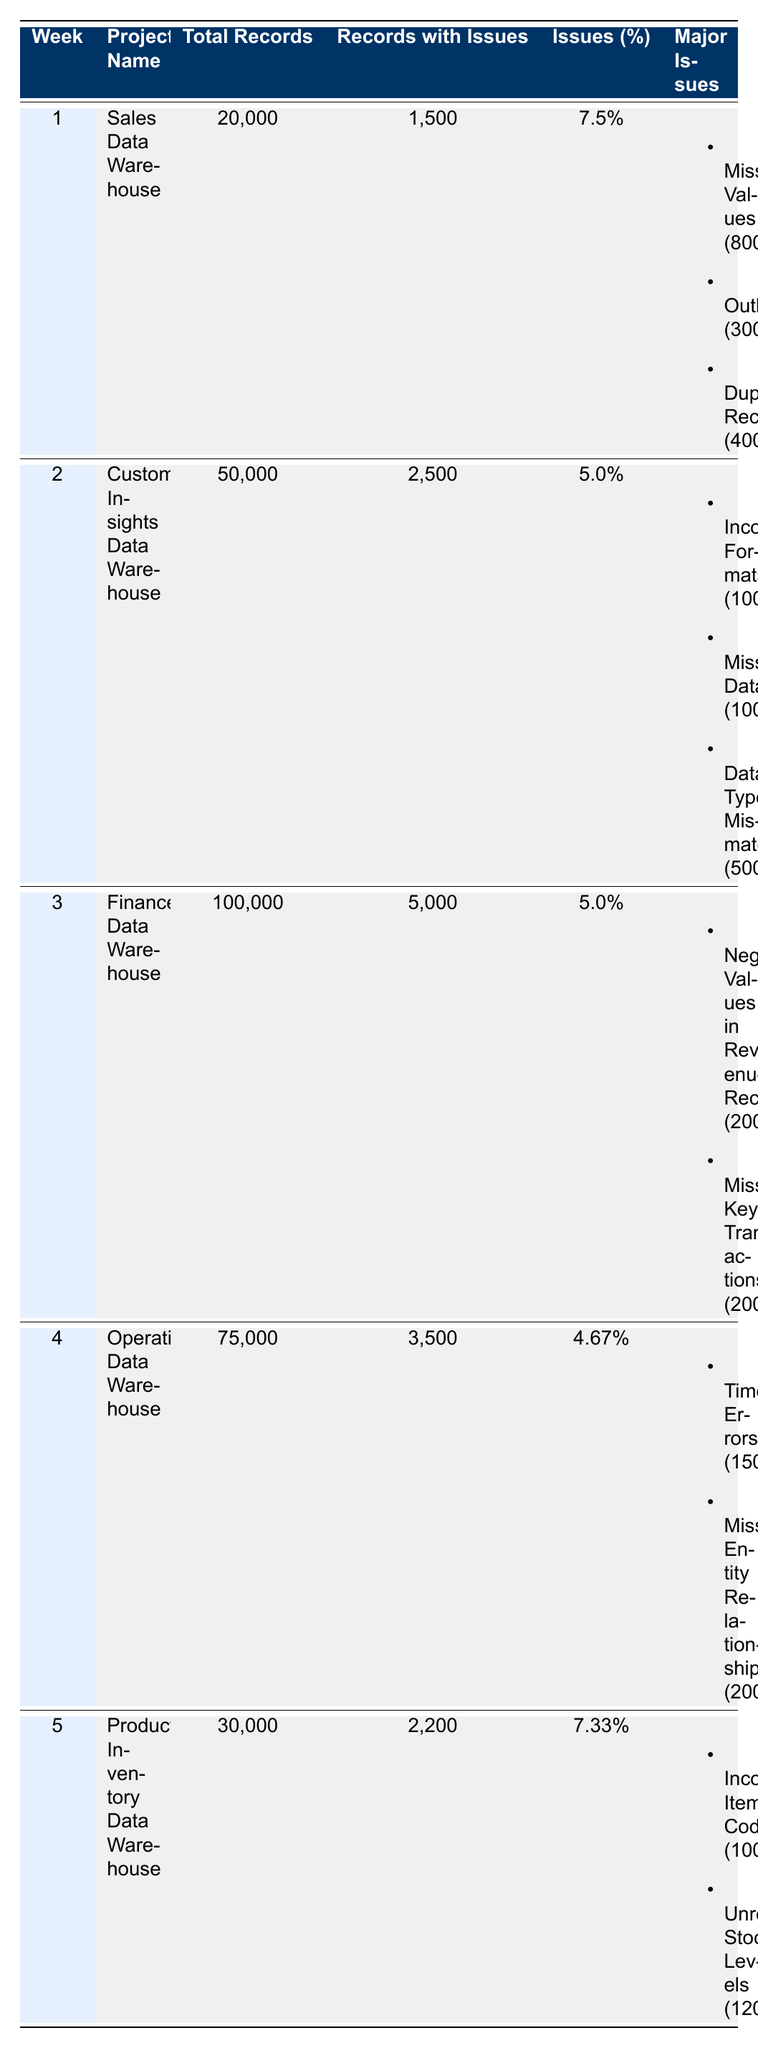What was the total number of records checked for the Finance Data Warehouse? The table shows that the total records checked for the Finance Data Warehouse on January 23, 2023, were 100,000.
Answer: 100000 How many records had issues in the Customer Insights Data Warehouse? According to the table, the Customer Insights Data Warehouse had 2,500 records with issues on January 16, 2023.
Answer: 2500 Which project had the highest percentage of issues? To find the highest percentage of issues, we look at the 'Issues (%)' column across all projects. The Sales Data Warehouse had 7.5%, which is higher than the others: 5.0%, 5.0%, 4.67%, and 7.33%. Thus, it had the highest percentage.
Answer: Sales Data Warehouse What is the average number of records checked across all projects listed? The total number of records checked is 20,000 + 50,000 + 100,000 + 75,000 + 30,000 = 275,000. There are 5 projects, so the average is 275,000 / 5 = 55,000.
Answer: 55000 Did any project have negative values in revenue records as a major issue? Yes, the Finance Data Warehouse had negative values in revenue records as a major issue, with a count of 2,000.
Answer: Yes What actions are recommended for addressing missing values in the Sales Data Warehouse? The table recommends implementing validation checks for data entry and reviewing the ETL process to handle missing values.
Answer: Implement validation checks and review ETL process Which project's major issues included timestamp errors? In the table, the Operational Data Warehouse, assessed on January 30, 2023, has timestamp errors listed as a major issue, with a count of 1,500.
Answer: Operational Data Warehouse How many total records were checked for the Product Inventory Data Warehouse, and how many had issues? The Product Inventory Data Warehouse had 30,000 records checked, with 2,200 of those records identified as having issues.
Answer: 30000, 2200 What is the total count of the major issues identified in the Finance Data Warehouse? The major issues in the Finance Data Warehouse include negative values in revenue records (2,000) and missing key transactions (2,000). Therefore, the total count is 2,000 + 2,000 = 4,000.
Answer: 4000 